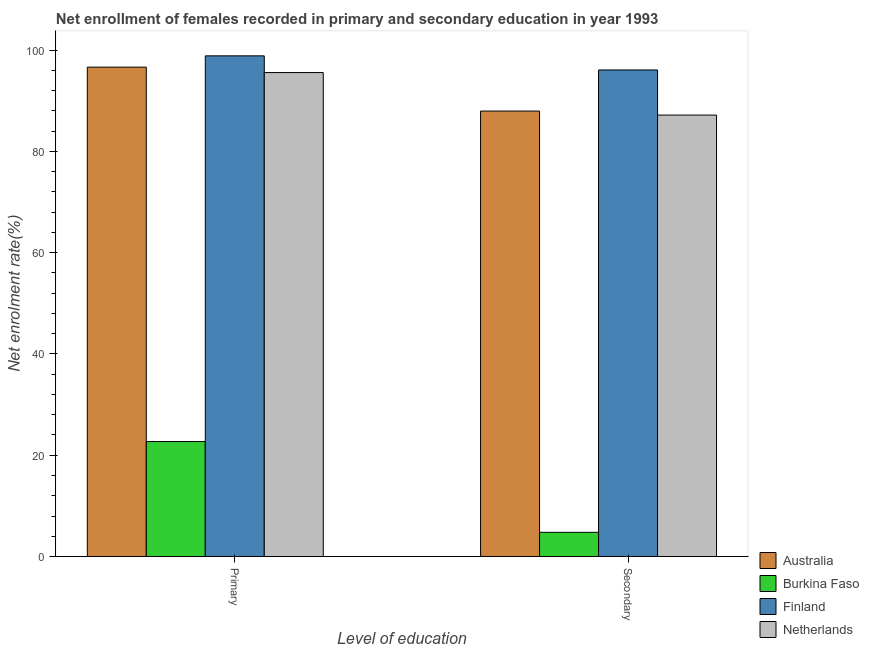How many groups of bars are there?
Your answer should be compact. 2. How many bars are there on the 1st tick from the left?
Provide a succinct answer. 4. How many bars are there on the 2nd tick from the right?
Your answer should be compact. 4. What is the label of the 2nd group of bars from the left?
Give a very brief answer. Secondary. What is the enrollment rate in primary education in Netherlands?
Offer a terse response. 95.55. Across all countries, what is the maximum enrollment rate in primary education?
Give a very brief answer. 98.85. Across all countries, what is the minimum enrollment rate in primary education?
Provide a succinct answer. 22.7. In which country was the enrollment rate in primary education minimum?
Ensure brevity in your answer.  Burkina Faso. What is the total enrollment rate in secondary education in the graph?
Provide a succinct answer. 275.95. What is the difference between the enrollment rate in primary education in Netherlands and that in Burkina Faso?
Your answer should be very brief. 72.85. What is the difference between the enrollment rate in secondary education in Burkina Faso and the enrollment rate in primary education in Australia?
Provide a short and direct response. -91.84. What is the average enrollment rate in secondary education per country?
Give a very brief answer. 68.99. What is the difference between the enrollment rate in secondary education and enrollment rate in primary education in Australia?
Your response must be concise. -8.67. In how many countries, is the enrollment rate in primary education greater than 48 %?
Give a very brief answer. 3. What is the ratio of the enrollment rate in secondary education in Netherlands to that in Australia?
Give a very brief answer. 0.99. What does the 3rd bar from the right in Secondary represents?
Your response must be concise. Burkina Faso. Are all the bars in the graph horizontal?
Your answer should be very brief. No. What is the difference between two consecutive major ticks on the Y-axis?
Your response must be concise. 20. Does the graph contain any zero values?
Your response must be concise. No. Does the graph contain grids?
Offer a terse response. No. Where does the legend appear in the graph?
Offer a terse response. Bottom right. How many legend labels are there?
Keep it short and to the point. 4. What is the title of the graph?
Keep it short and to the point. Net enrollment of females recorded in primary and secondary education in year 1993. What is the label or title of the X-axis?
Offer a terse response. Level of education. What is the label or title of the Y-axis?
Ensure brevity in your answer.  Net enrolment rate(%). What is the Net enrolment rate(%) of Australia in Primary?
Provide a short and direct response. 96.62. What is the Net enrolment rate(%) in Burkina Faso in Primary?
Offer a very short reply. 22.7. What is the Net enrolment rate(%) of Finland in Primary?
Your answer should be very brief. 98.85. What is the Net enrolment rate(%) of Netherlands in Primary?
Provide a short and direct response. 95.55. What is the Net enrolment rate(%) in Australia in Secondary?
Provide a succinct answer. 87.95. What is the Net enrolment rate(%) in Burkina Faso in Secondary?
Provide a succinct answer. 4.78. What is the Net enrolment rate(%) of Finland in Secondary?
Give a very brief answer. 96.06. What is the Net enrolment rate(%) of Netherlands in Secondary?
Your answer should be very brief. 87.16. Across all Level of education, what is the maximum Net enrolment rate(%) of Australia?
Provide a succinct answer. 96.62. Across all Level of education, what is the maximum Net enrolment rate(%) of Burkina Faso?
Make the answer very short. 22.7. Across all Level of education, what is the maximum Net enrolment rate(%) of Finland?
Offer a terse response. 98.85. Across all Level of education, what is the maximum Net enrolment rate(%) in Netherlands?
Give a very brief answer. 95.55. Across all Level of education, what is the minimum Net enrolment rate(%) of Australia?
Ensure brevity in your answer.  87.95. Across all Level of education, what is the minimum Net enrolment rate(%) of Burkina Faso?
Ensure brevity in your answer.  4.78. Across all Level of education, what is the minimum Net enrolment rate(%) in Finland?
Give a very brief answer. 96.06. Across all Level of education, what is the minimum Net enrolment rate(%) in Netherlands?
Your response must be concise. 87.16. What is the total Net enrolment rate(%) of Australia in the graph?
Offer a very short reply. 184.57. What is the total Net enrolment rate(%) in Burkina Faso in the graph?
Provide a succinct answer. 27.48. What is the total Net enrolment rate(%) in Finland in the graph?
Your answer should be compact. 194.91. What is the total Net enrolment rate(%) in Netherlands in the graph?
Keep it short and to the point. 182.71. What is the difference between the Net enrolment rate(%) of Australia in Primary and that in Secondary?
Offer a terse response. 8.67. What is the difference between the Net enrolment rate(%) in Burkina Faso in Primary and that in Secondary?
Offer a very short reply. 17.92. What is the difference between the Net enrolment rate(%) in Finland in Primary and that in Secondary?
Ensure brevity in your answer.  2.78. What is the difference between the Net enrolment rate(%) of Netherlands in Primary and that in Secondary?
Offer a very short reply. 8.39. What is the difference between the Net enrolment rate(%) in Australia in Primary and the Net enrolment rate(%) in Burkina Faso in Secondary?
Your response must be concise. 91.84. What is the difference between the Net enrolment rate(%) in Australia in Primary and the Net enrolment rate(%) in Finland in Secondary?
Your response must be concise. 0.56. What is the difference between the Net enrolment rate(%) of Australia in Primary and the Net enrolment rate(%) of Netherlands in Secondary?
Your answer should be compact. 9.46. What is the difference between the Net enrolment rate(%) of Burkina Faso in Primary and the Net enrolment rate(%) of Finland in Secondary?
Provide a short and direct response. -73.36. What is the difference between the Net enrolment rate(%) in Burkina Faso in Primary and the Net enrolment rate(%) in Netherlands in Secondary?
Provide a short and direct response. -64.46. What is the difference between the Net enrolment rate(%) of Finland in Primary and the Net enrolment rate(%) of Netherlands in Secondary?
Ensure brevity in your answer.  11.69. What is the average Net enrolment rate(%) in Australia per Level of education?
Your answer should be very brief. 92.29. What is the average Net enrolment rate(%) of Burkina Faso per Level of education?
Provide a short and direct response. 13.74. What is the average Net enrolment rate(%) in Finland per Level of education?
Give a very brief answer. 97.46. What is the average Net enrolment rate(%) of Netherlands per Level of education?
Your answer should be compact. 91.36. What is the difference between the Net enrolment rate(%) in Australia and Net enrolment rate(%) in Burkina Faso in Primary?
Make the answer very short. 73.92. What is the difference between the Net enrolment rate(%) of Australia and Net enrolment rate(%) of Finland in Primary?
Your answer should be very brief. -2.23. What is the difference between the Net enrolment rate(%) of Australia and Net enrolment rate(%) of Netherlands in Primary?
Keep it short and to the point. 1.07. What is the difference between the Net enrolment rate(%) in Burkina Faso and Net enrolment rate(%) in Finland in Primary?
Ensure brevity in your answer.  -76.15. What is the difference between the Net enrolment rate(%) of Burkina Faso and Net enrolment rate(%) of Netherlands in Primary?
Ensure brevity in your answer.  -72.85. What is the difference between the Net enrolment rate(%) in Finland and Net enrolment rate(%) in Netherlands in Primary?
Give a very brief answer. 3.3. What is the difference between the Net enrolment rate(%) of Australia and Net enrolment rate(%) of Burkina Faso in Secondary?
Provide a short and direct response. 83.17. What is the difference between the Net enrolment rate(%) of Australia and Net enrolment rate(%) of Finland in Secondary?
Offer a very short reply. -8.12. What is the difference between the Net enrolment rate(%) of Australia and Net enrolment rate(%) of Netherlands in Secondary?
Provide a succinct answer. 0.79. What is the difference between the Net enrolment rate(%) in Burkina Faso and Net enrolment rate(%) in Finland in Secondary?
Offer a terse response. -91.28. What is the difference between the Net enrolment rate(%) in Burkina Faso and Net enrolment rate(%) in Netherlands in Secondary?
Ensure brevity in your answer.  -82.38. What is the difference between the Net enrolment rate(%) in Finland and Net enrolment rate(%) in Netherlands in Secondary?
Your response must be concise. 8.91. What is the ratio of the Net enrolment rate(%) of Australia in Primary to that in Secondary?
Your answer should be compact. 1.1. What is the ratio of the Net enrolment rate(%) of Burkina Faso in Primary to that in Secondary?
Make the answer very short. 4.75. What is the ratio of the Net enrolment rate(%) of Finland in Primary to that in Secondary?
Make the answer very short. 1.03. What is the ratio of the Net enrolment rate(%) of Netherlands in Primary to that in Secondary?
Provide a short and direct response. 1.1. What is the difference between the highest and the second highest Net enrolment rate(%) in Australia?
Your answer should be compact. 8.67. What is the difference between the highest and the second highest Net enrolment rate(%) of Burkina Faso?
Ensure brevity in your answer.  17.92. What is the difference between the highest and the second highest Net enrolment rate(%) in Finland?
Make the answer very short. 2.78. What is the difference between the highest and the second highest Net enrolment rate(%) in Netherlands?
Your answer should be very brief. 8.39. What is the difference between the highest and the lowest Net enrolment rate(%) of Australia?
Ensure brevity in your answer.  8.67. What is the difference between the highest and the lowest Net enrolment rate(%) of Burkina Faso?
Give a very brief answer. 17.92. What is the difference between the highest and the lowest Net enrolment rate(%) of Finland?
Provide a succinct answer. 2.78. What is the difference between the highest and the lowest Net enrolment rate(%) in Netherlands?
Offer a terse response. 8.39. 